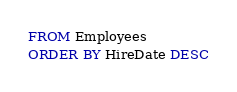<code> <loc_0><loc_0><loc_500><loc_500><_SQL_>FROM Employees
ORDER BY HireDate DESC</code> 